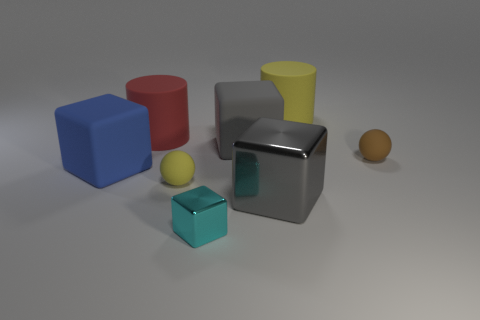How many cubes are both to the right of the large red cylinder and behind the large gray metal thing?
Give a very brief answer. 1. Do the large block that is behind the tiny brown object and the blue thing have the same material?
Your response must be concise. Yes. There is a yellow object that is behind the large cube on the left side of the yellow object that is on the left side of the small cyan object; what is its shape?
Provide a short and direct response. Cylinder. Is the number of blocks that are behind the large gray metal cube the same as the number of big metal cubes behind the big gray matte thing?
Your answer should be very brief. No. What is the color of the shiny cube that is the same size as the yellow sphere?
Your answer should be compact. Cyan. How many large objects are either yellow rubber cylinders or rubber cylinders?
Make the answer very short. 2. What is the large cube that is both behind the small yellow matte object and right of the small cyan cube made of?
Provide a short and direct response. Rubber. Does the small object that is behind the blue object have the same shape as the tiny object in front of the big gray metallic block?
Your answer should be compact. No. There is a big matte thing that is the same color as the big metal thing; what shape is it?
Give a very brief answer. Cube. How many things are either rubber objects that are behind the big blue rubber cube or big blue things?
Your response must be concise. 5. 